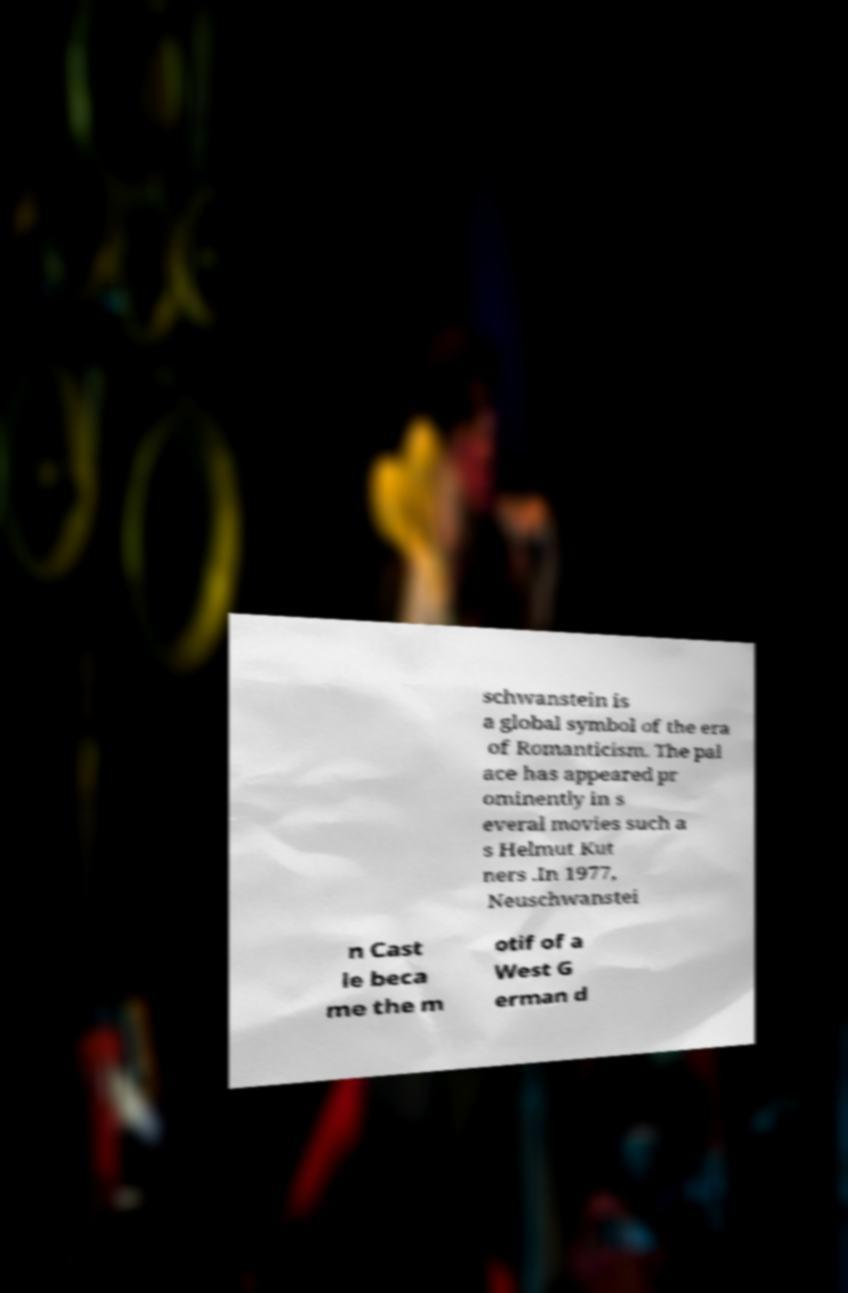Could you extract and type out the text from this image? schwanstein is a global symbol of the era of Romanticism. The pal ace has appeared pr ominently in s everal movies such a s Helmut Kut ners .In 1977, Neuschwanstei n Cast le beca me the m otif of a West G erman d 